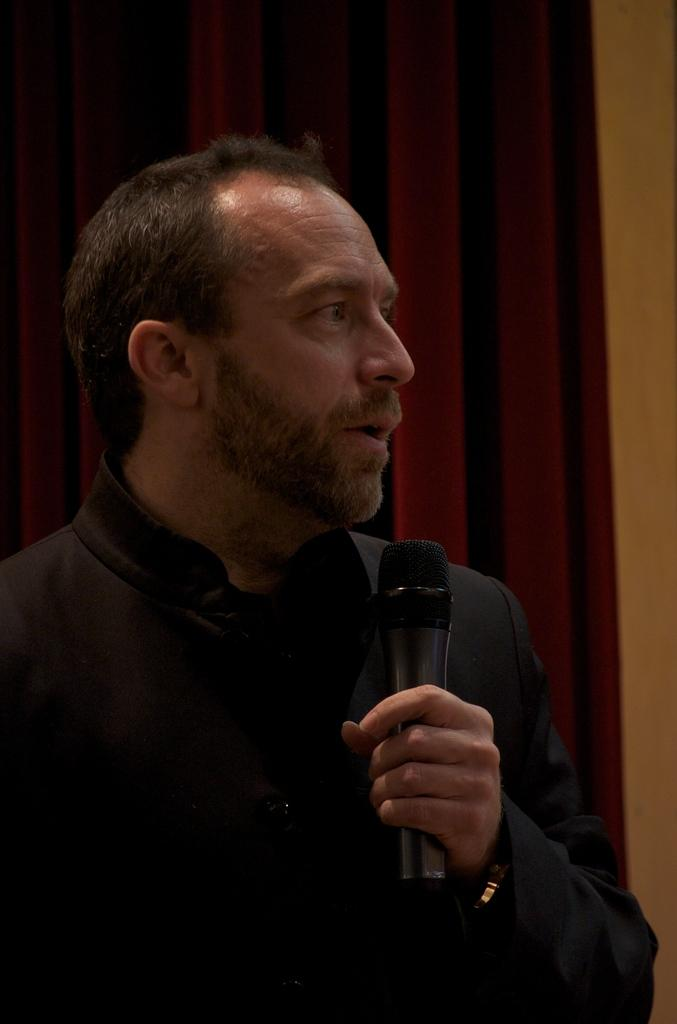Who is the main subject in the image? There is a man in the image. What is the man holding in the image? The man is holding a mic. What can be seen in the background of the image? There is a red curtain and a wall in the background of the image. What rule is the man breaking in the image? There is no indication in the image that the man is breaking any rules. What nerve is the man stimulating in the image? There is no mention of nerves or stimulation in the image; it simply shows a man holding a mic. 